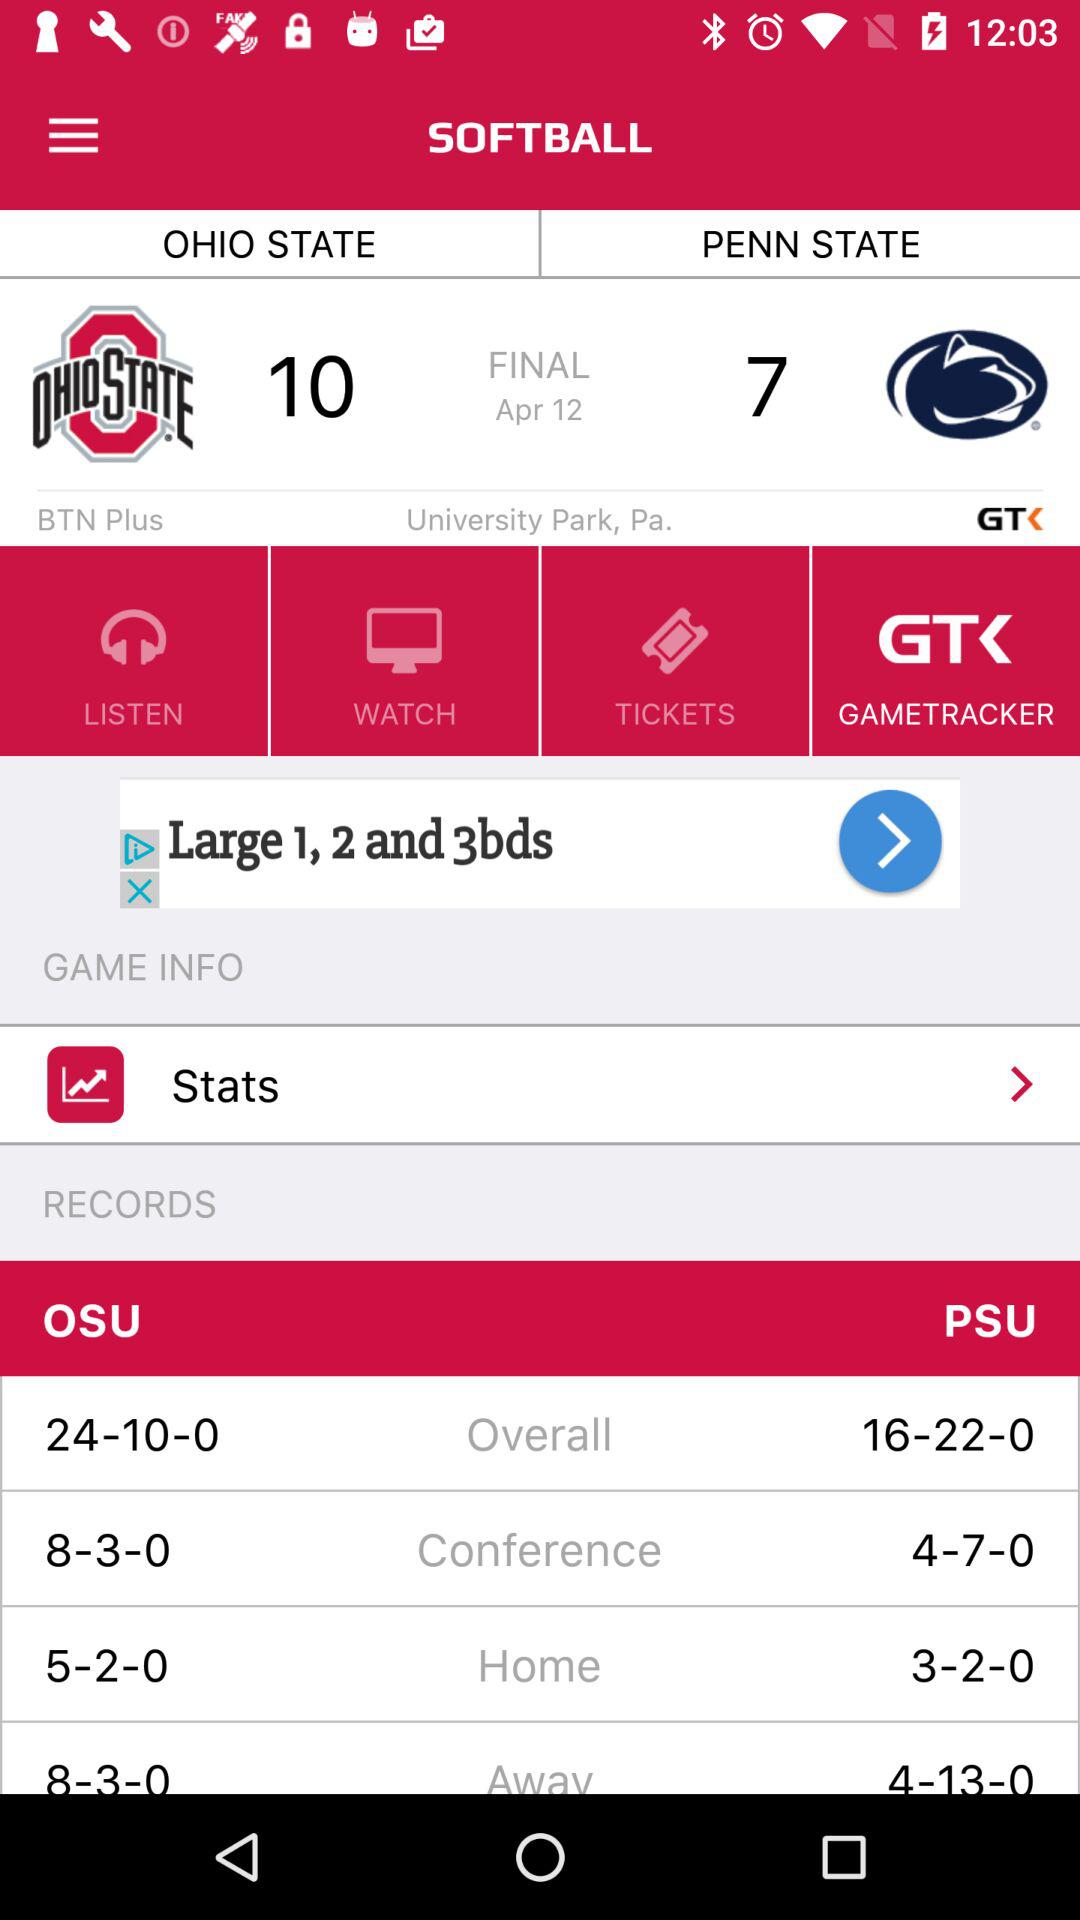How many more wins did OSU have in conference play than PSU?
Answer the question using a single word or phrase. 4 